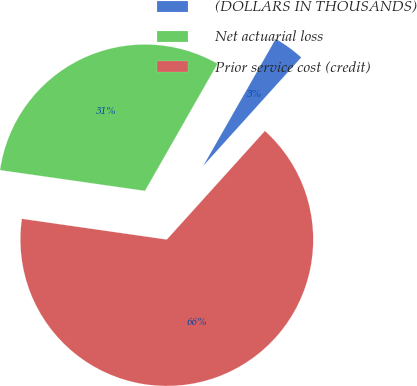Convert chart. <chart><loc_0><loc_0><loc_500><loc_500><pie_chart><fcel>(DOLLARS IN THOUSANDS)<fcel>Net actuarial loss<fcel>Prior service cost (credit)<nl><fcel>3.44%<fcel>30.99%<fcel>65.58%<nl></chart> 